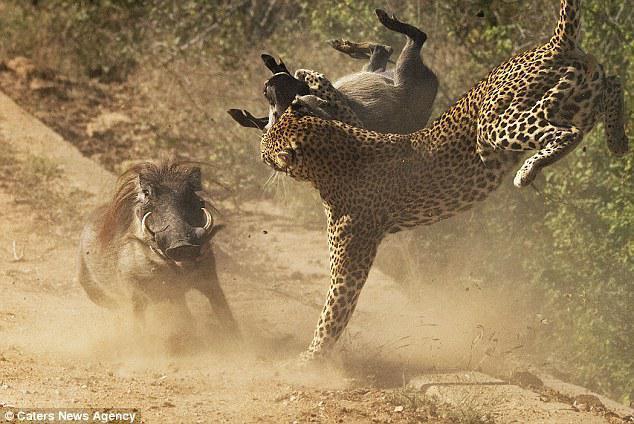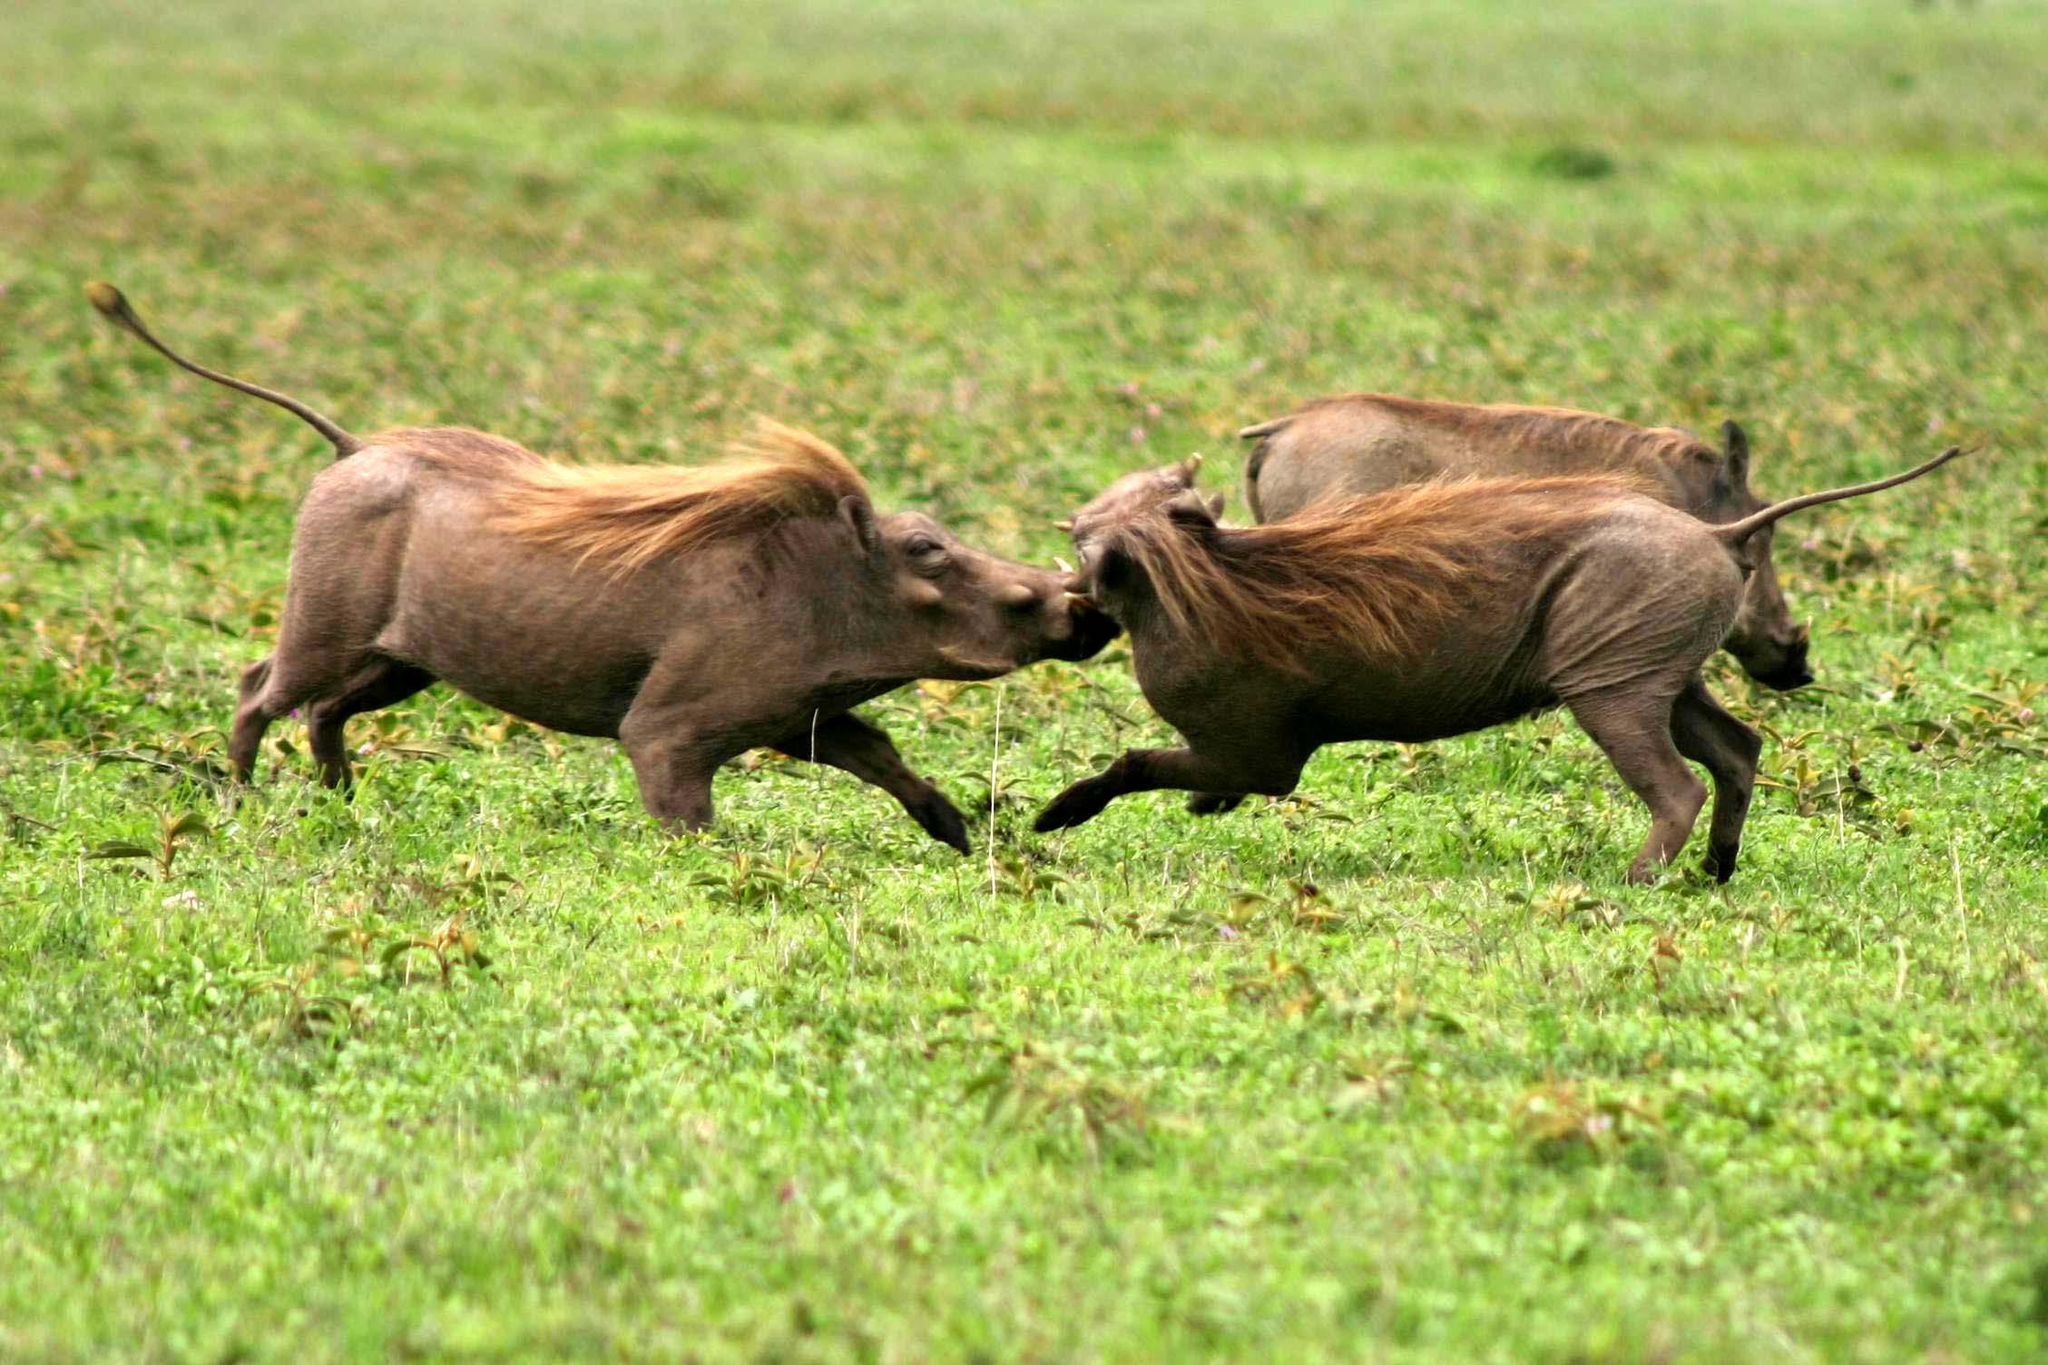The first image is the image on the left, the second image is the image on the right. Evaluate the accuracy of this statement regarding the images: "A hog's leg is bleeding while it fights another hog.". Is it true? Answer yes or no. No. 